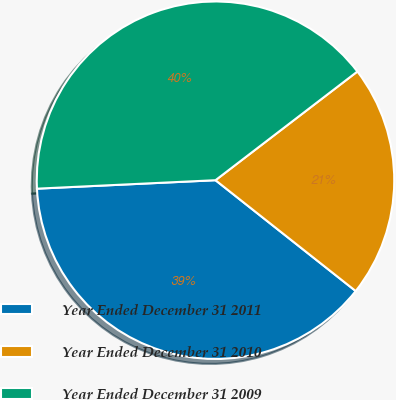Convert chart to OTSL. <chart><loc_0><loc_0><loc_500><loc_500><pie_chart><fcel>Year Ended December 31 2011<fcel>Year Ended December 31 2010<fcel>Year Ended December 31 2009<nl><fcel>38.6%<fcel>21.05%<fcel>40.35%<nl></chart> 